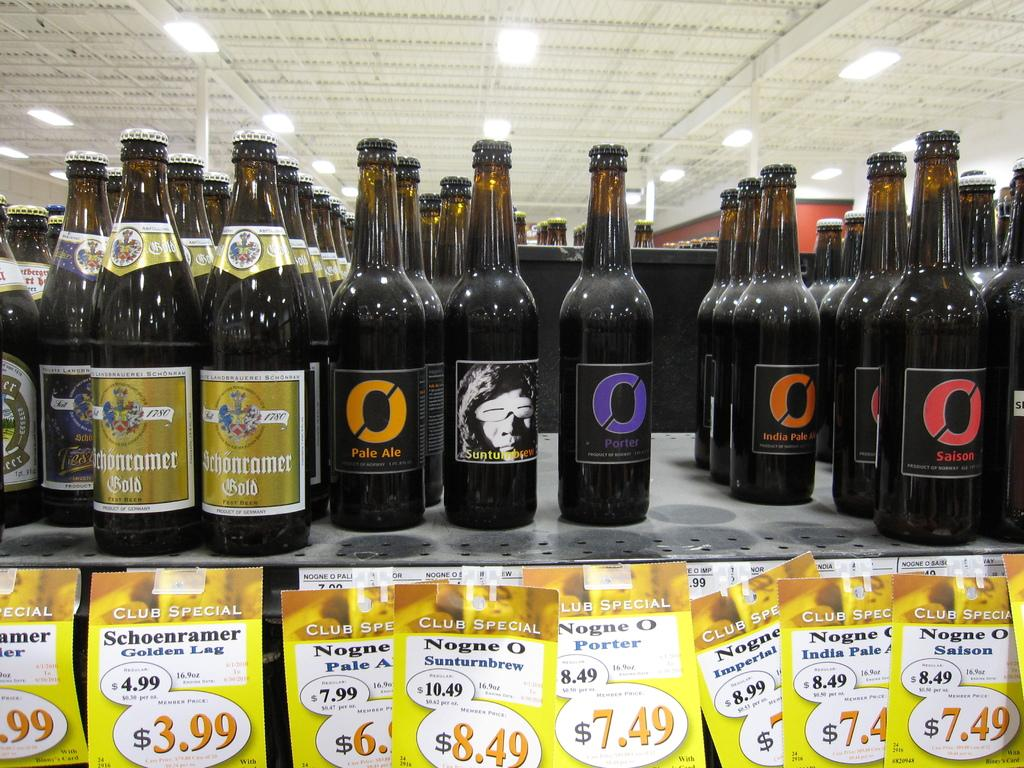<image>
Give a short and clear explanation of the subsequent image. Several bottles for sale on a store shelf, including Porter and Pale Ale. 